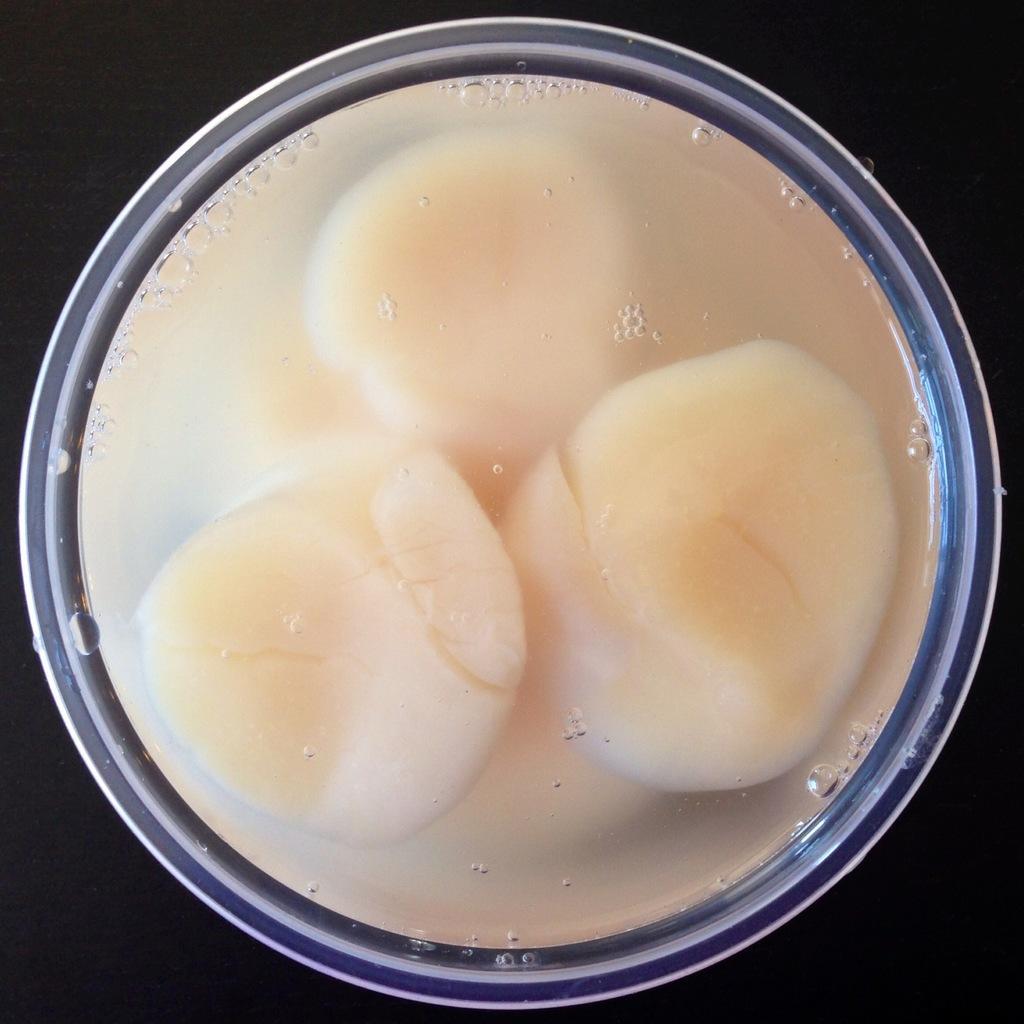How would you summarize this image in a sentence or two? In the image we can see bowl, in the bowl there is water and white color objects. 